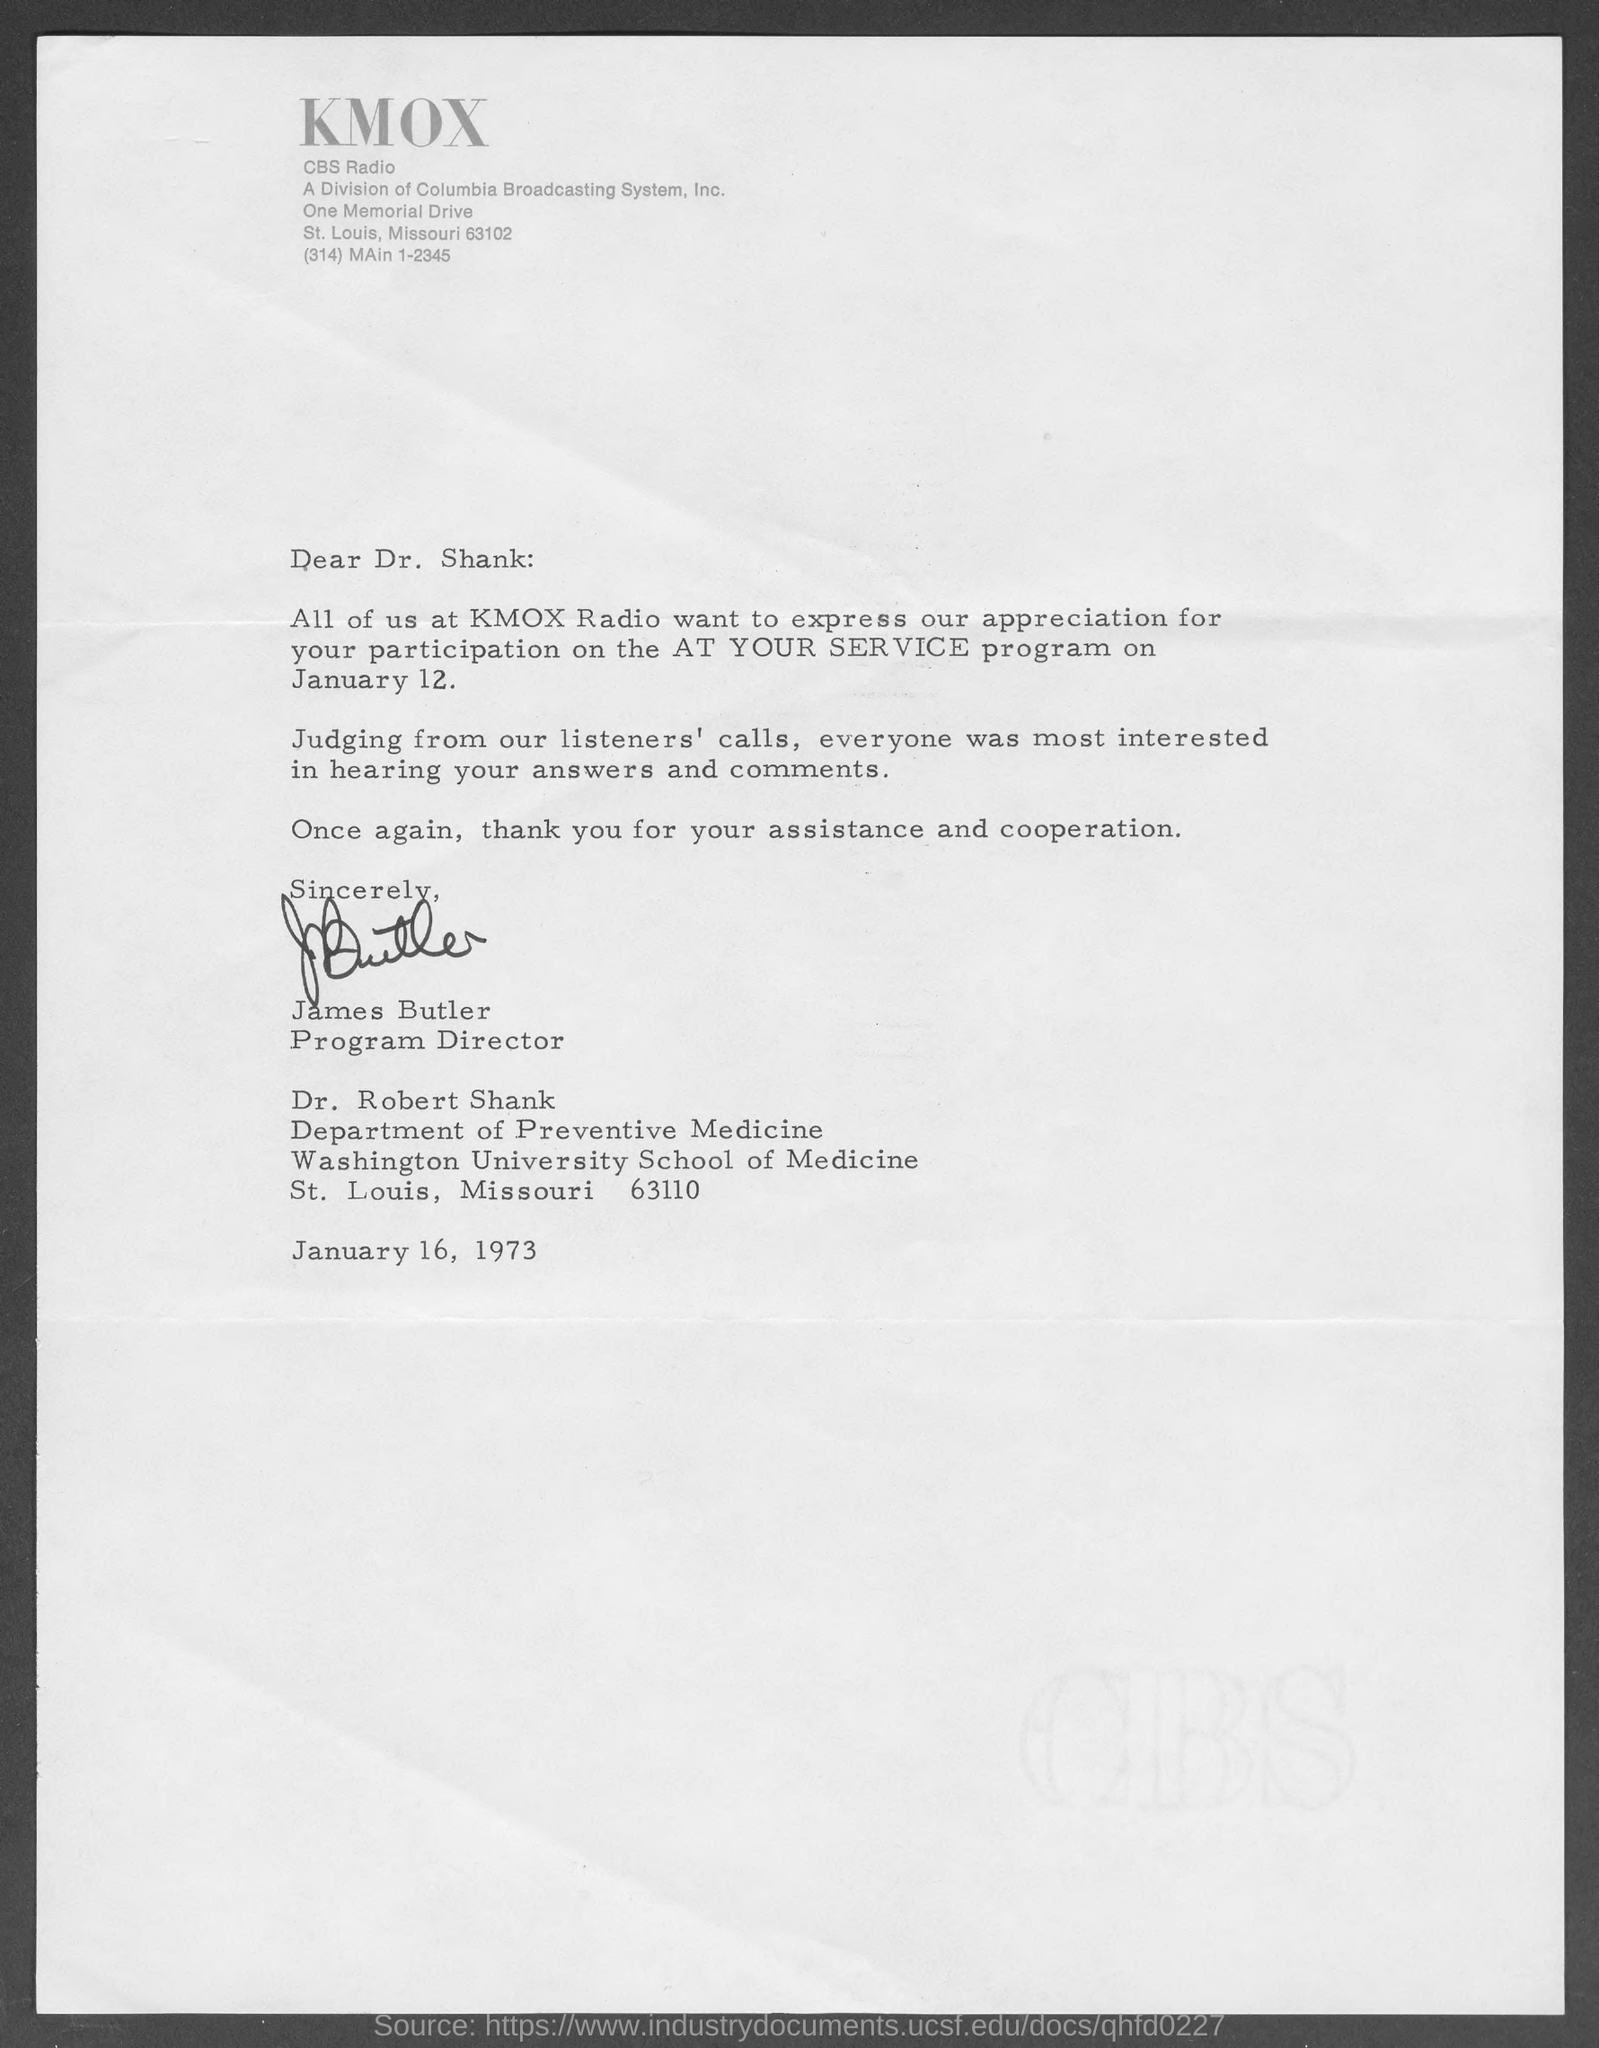What is the program name?
Provide a succinct answer. AT YOUR SERVICE. Who is the program director at KMOX Radio?
Offer a very short reply. James Butler. 